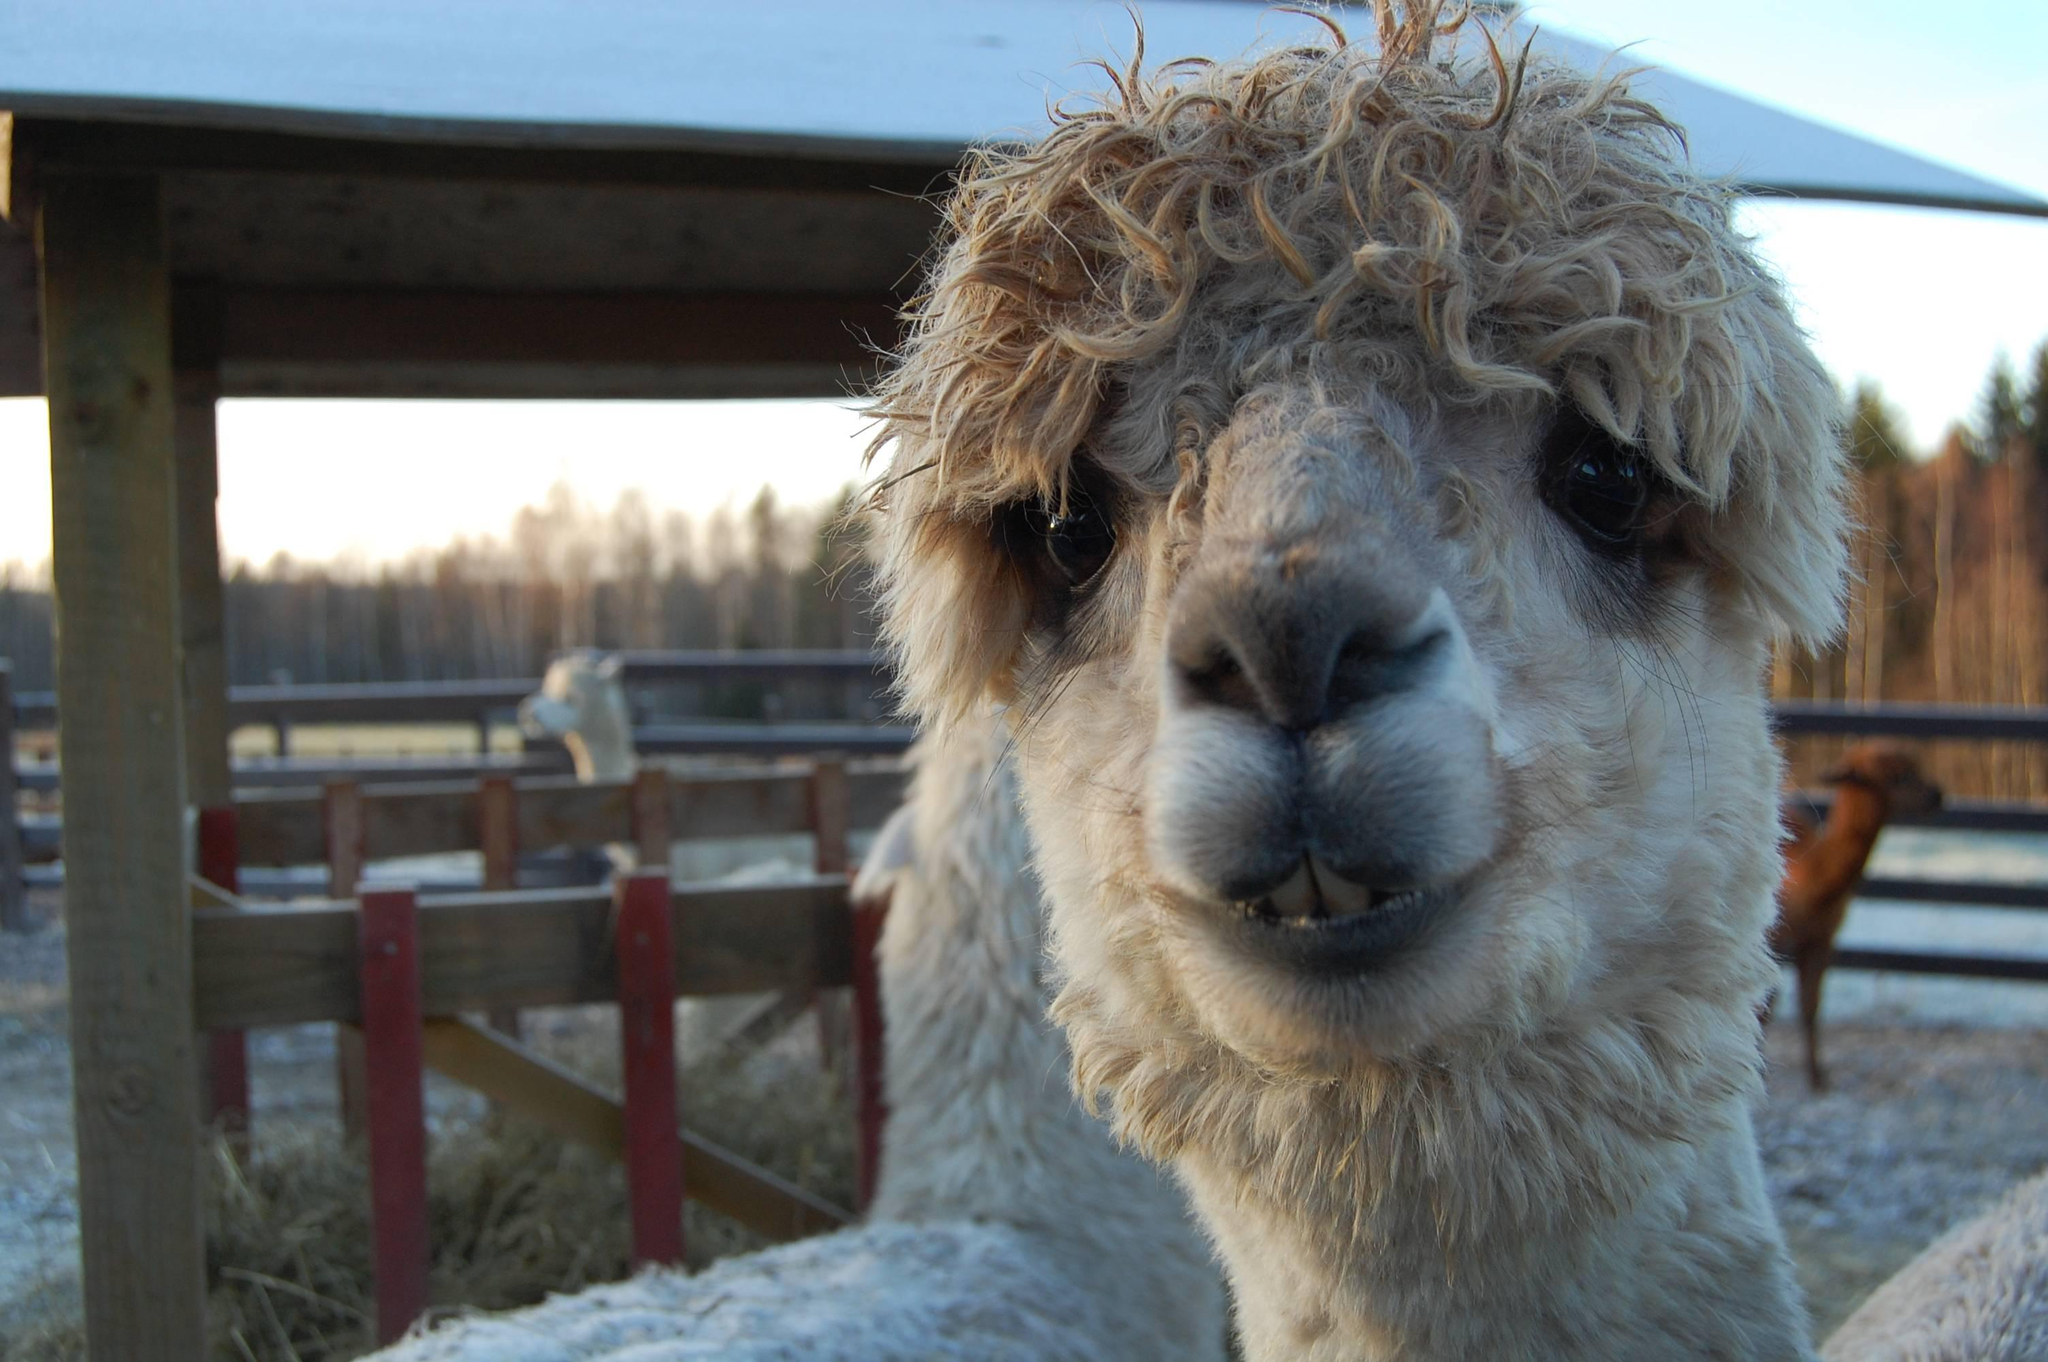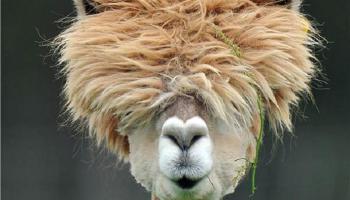The first image is the image on the left, the second image is the image on the right. Examine the images to the left and right. Is the description "Four llama eyes are visible." accurate? Answer yes or no. No. 